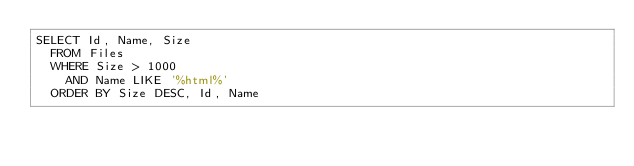<code> <loc_0><loc_0><loc_500><loc_500><_SQL_>SELECT Id, Name, Size
	FROM Files
	WHERE Size > 1000
		AND Name LIKE '%html%'
	ORDER BY Size DESC, Id, Name</code> 